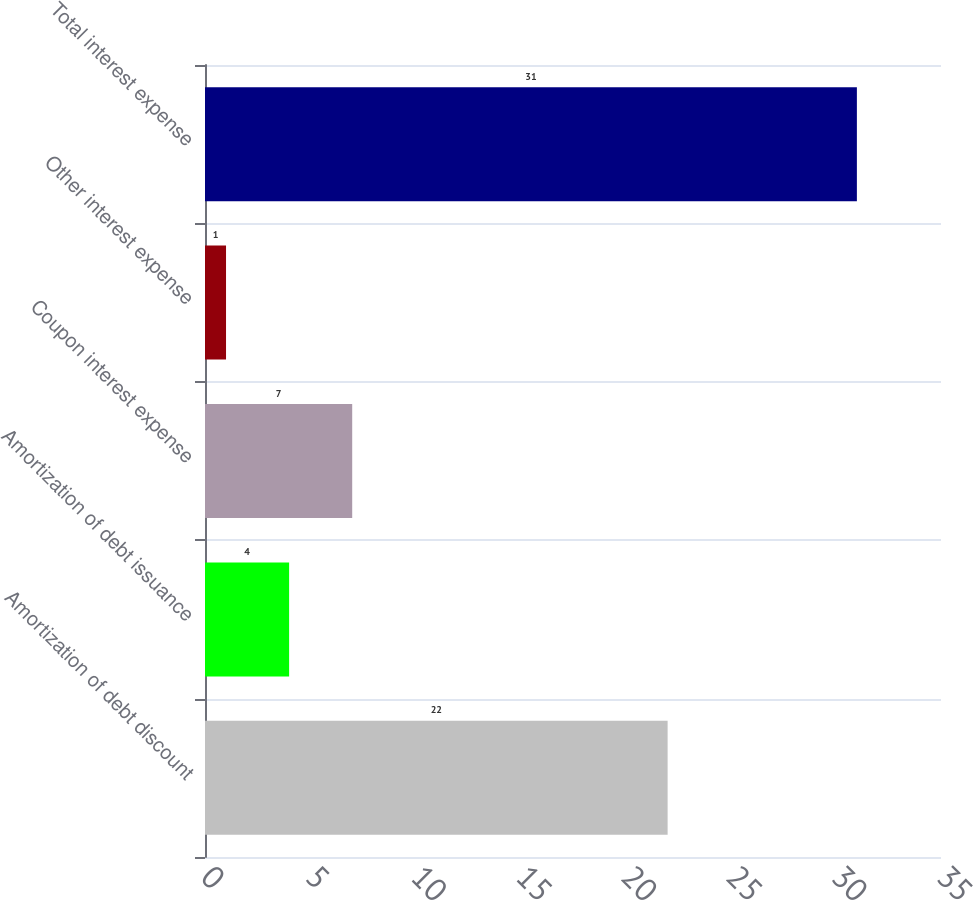Convert chart to OTSL. <chart><loc_0><loc_0><loc_500><loc_500><bar_chart><fcel>Amortization of debt discount<fcel>Amortization of debt issuance<fcel>Coupon interest expense<fcel>Other interest expense<fcel>Total interest expense<nl><fcel>22<fcel>4<fcel>7<fcel>1<fcel>31<nl></chart> 